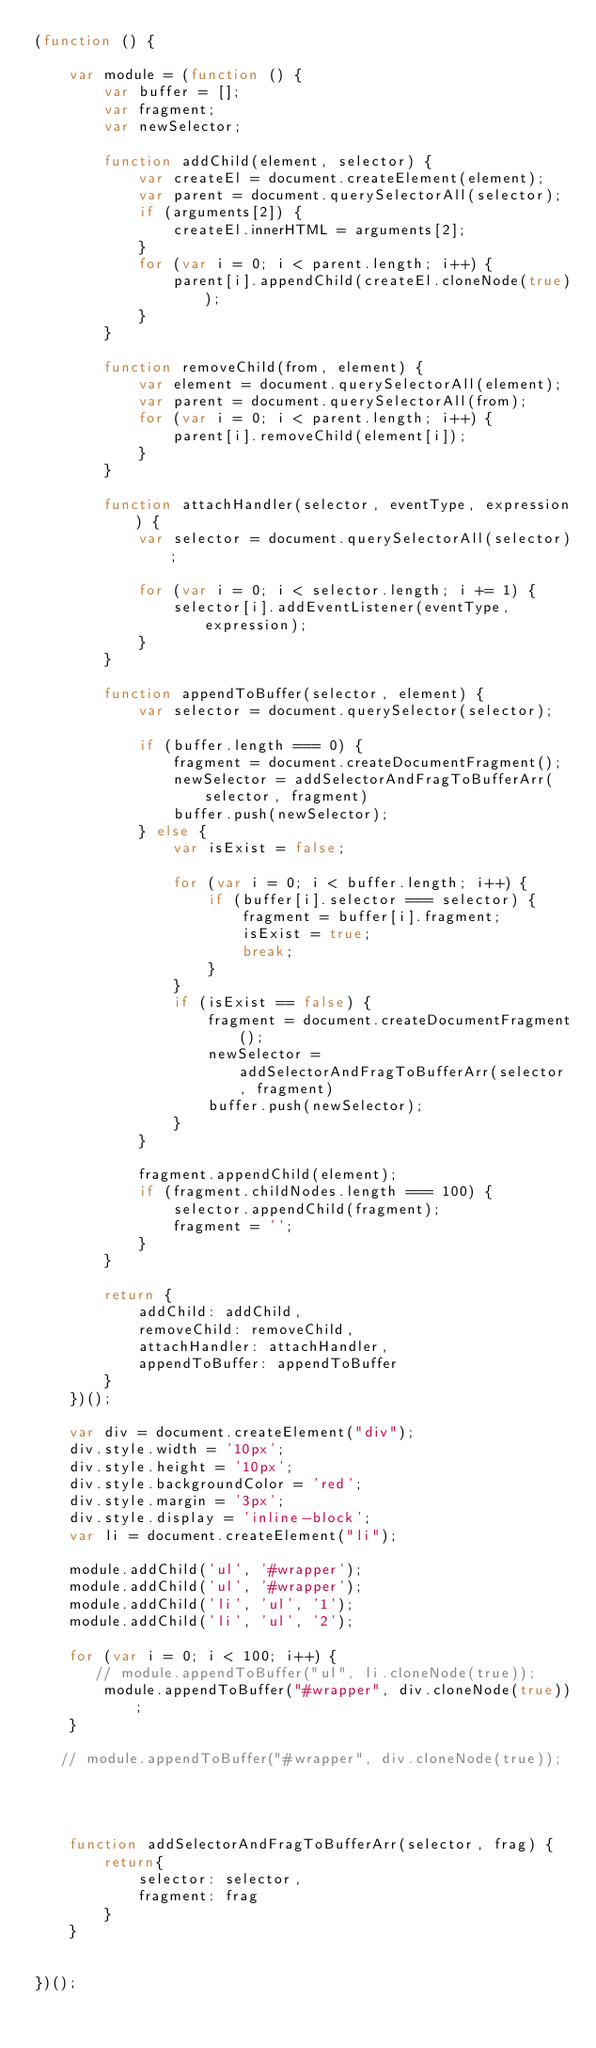<code> <loc_0><loc_0><loc_500><loc_500><_JavaScript_>(function () {

    var module = (function () {
        var buffer = [];
        var fragment;
        var newSelector;

        function addChild(element, selector) {
            var createEl = document.createElement(element);
            var parent = document.querySelectorAll(selector);
            if (arguments[2]) {
                createEl.innerHTML = arguments[2];
            }
            for (var i = 0; i < parent.length; i++) {
                parent[i].appendChild(createEl.cloneNode(true));
            }
        }

        function removeChild(from, element) {
            var element = document.querySelectorAll(element);
            var parent = document.querySelectorAll(from);
            for (var i = 0; i < parent.length; i++) {
                parent[i].removeChild(element[i]);
            }
        }

        function attachHandler(selector, eventType, expression) {
            var selector = document.querySelectorAll(selector);

            for (var i = 0; i < selector.length; i += 1) {
                selector[i].addEventListener(eventType, expression);
            }
        }

        function appendToBuffer(selector, element) {
            var selector = document.querySelector(selector);

            if (buffer.length === 0) {
                fragment = document.createDocumentFragment();
                newSelector = addSelectorAndFragToBufferArr(selector, fragment)
                buffer.push(newSelector);
            } else {
                var isExist = false;

                for (var i = 0; i < buffer.length; i++) {
                    if (buffer[i].selector === selector) {
                        fragment = buffer[i].fragment;
                        isExist = true;
                        break;
                    }
                }
                if (isExist == false) {
                    fragment = document.createDocumentFragment();
                    newSelector = addSelectorAndFragToBufferArr(selector, fragment)
                    buffer.push(newSelector);
                }
            }

            fragment.appendChild(element);
            if (fragment.childNodes.length === 100) {
                selector.appendChild(fragment);
                fragment = '';
            }
        }

        return {
            addChild: addChild,
            removeChild: removeChild,
            attachHandler: attachHandler,
            appendToBuffer: appendToBuffer
        }
    })();

    var div = document.createElement("div");
    div.style.width = '10px';
    div.style.height = '10px';
    div.style.backgroundColor = 'red';
    div.style.margin = '3px';
    div.style.display = 'inline-block';
    var li = document.createElement("li");

    module.addChild('ul', '#wrapper');
    module.addChild('ul', '#wrapper');
    module.addChild('li', 'ul', '1');
    module.addChild('li', 'ul', '2');

    for (var i = 0; i < 100; i++) {
       // module.appendToBuffer("ul", li.cloneNode(true));
        module.appendToBuffer("#wrapper", div.cloneNode(true));
    }

   // module.appendToBuffer("#wrapper", div.cloneNode(true));




    function addSelectorAndFragToBufferArr(selector, frag) {
        return{
            selector: selector,
            fragment: frag
        }
    }


})();



</code> 